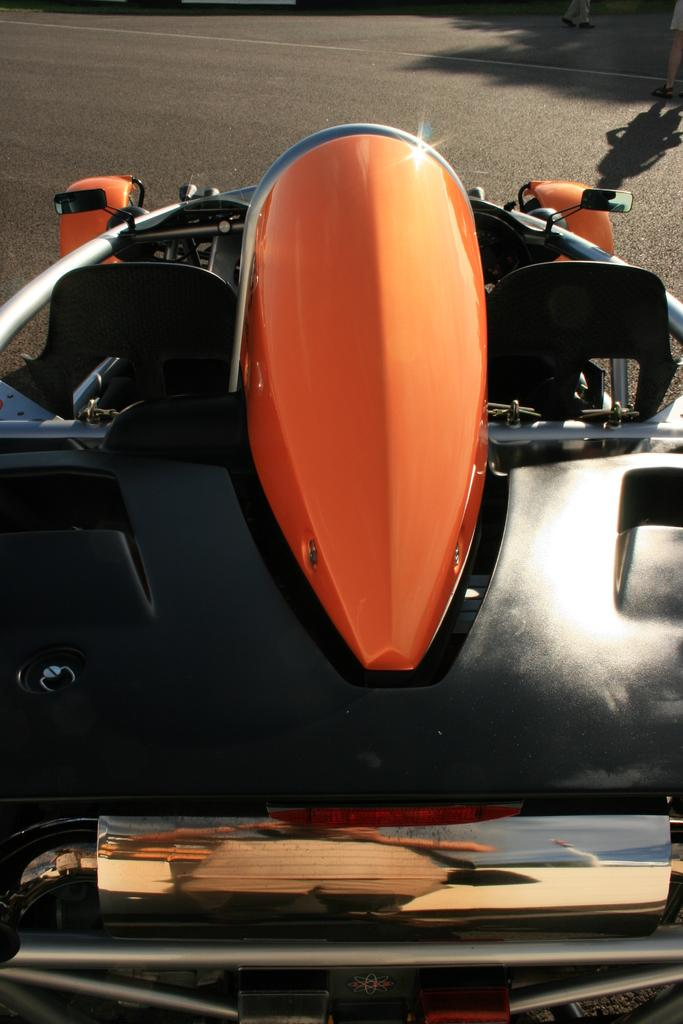What is the main subject of the image? There is a vehicle in the image. Where is the vehicle located? The vehicle is on the road. What type of bead is used to decorate the vessel in the image? There is no vessel or bead present in the image; it features a vehicle on the road. What kind of grain can be seen growing near the vehicle in the image? There is no grain visible in the image; it only shows a vehicle on the road. 